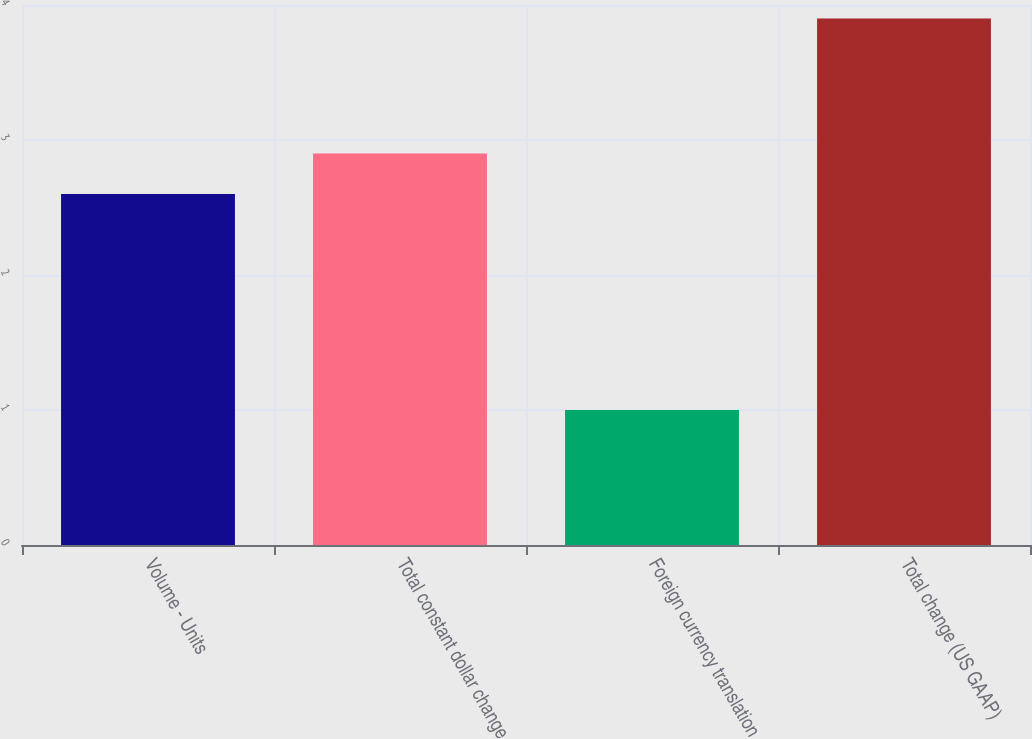Convert chart. <chart><loc_0><loc_0><loc_500><loc_500><bar_chart><fcel>Volume - Units<fcel>Total constant dollar change<fcel>Foreign currency translation<fcel>Total change (US GAAP)<nl><fcel>2.6<fcel>2.9<fcel>1<fcel>3.9<nl></chart> 